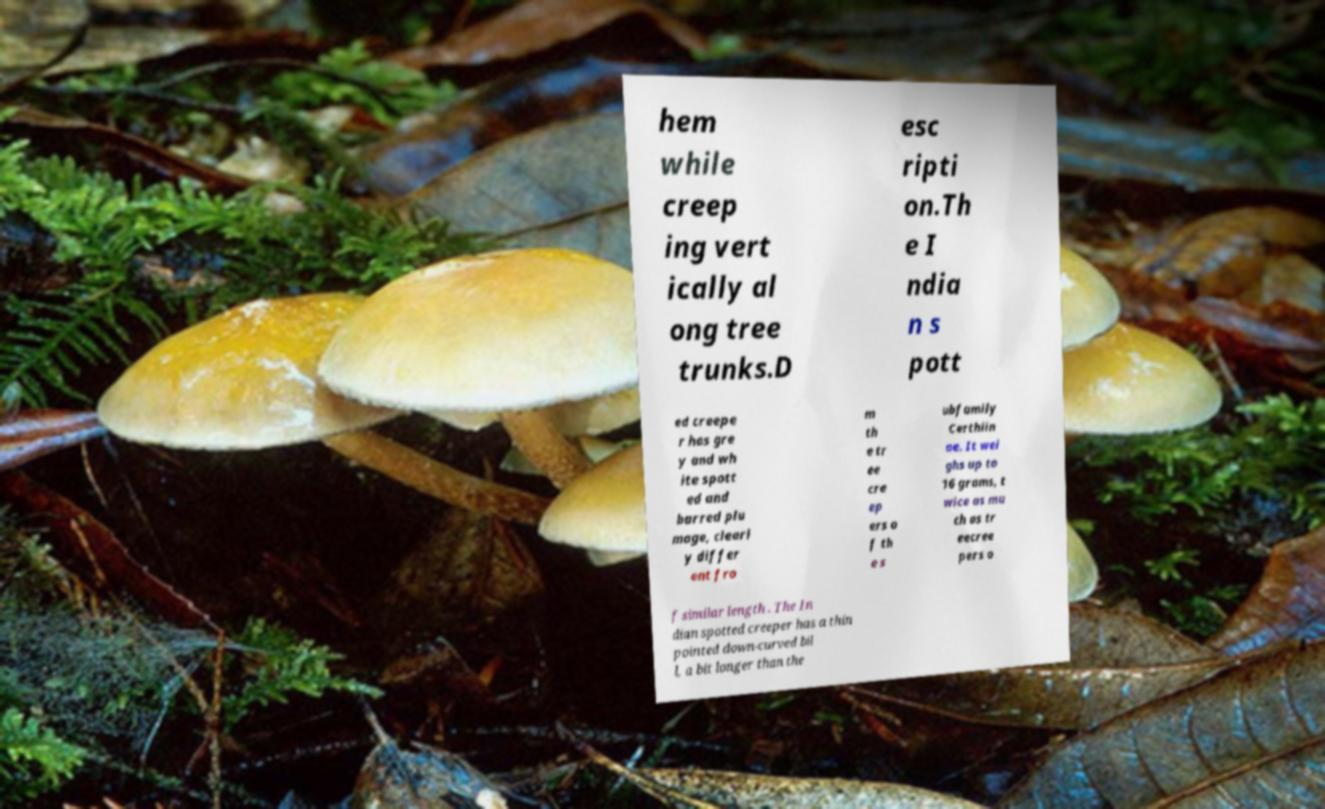Could you assist in decoding the text presented in this image and type it out clearly? hem while creep ing vert ically al ong tree trunks.D esc ripti on.Th e I ndia n s pott ed creepe r has gre y and wh ite spott ed and barred plu mage, clearl y differ ent fro m th e tr ee cre ep ers o f th e s ubfamily Certhiin ae. It wei ghs up to 16 grams, t wice as mu ch as tr eecree pers o f similar length . The In dian spotted creeper has a thin pointed down-curved bil l, a bit longer than the 